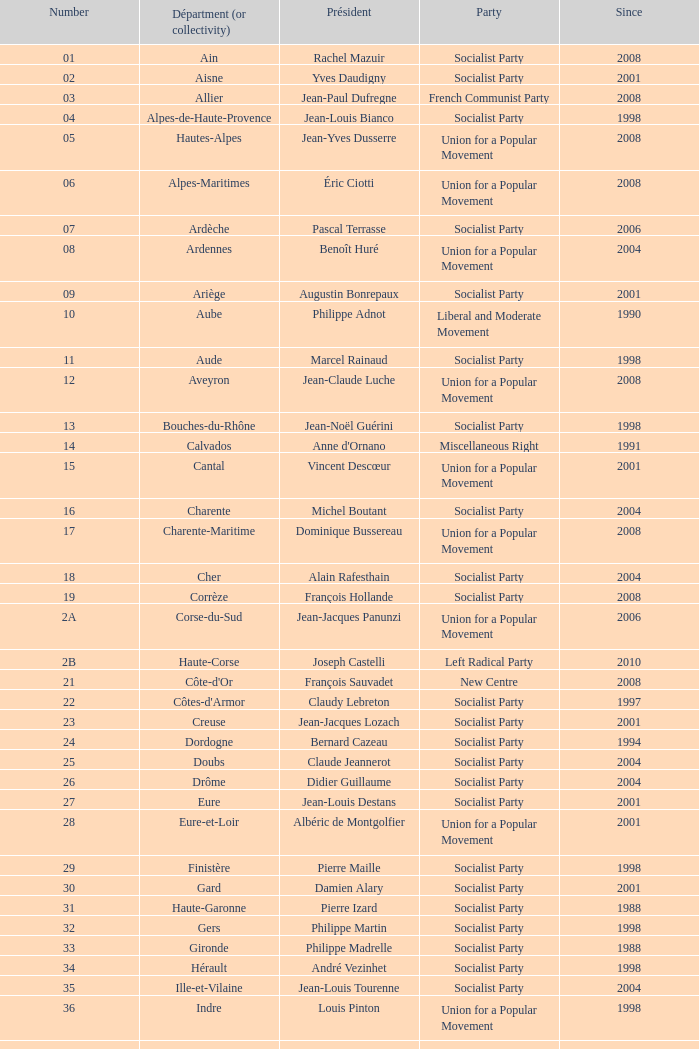Who is the president embodying the creuse department? Jean-Jacques Lozach. Could you parse the entire table? {'header': ['Number', 'Départment (or collectivity)', 'Président', 'Party', 'Since'], 'rows': [['01', 'Ain', 'Rachel Mazuir', 'Socialist Party', '2008'], ['02', 'Aisne', 'Yves Daudigny', 'Socialist Party', '2001'], ['03', 'Allier', 'Jean-Paul Dufregne', 'French Communist Party', '2008'], ['04', 'Alpes-de-Haute-Provence', 'Jean-Louis Bianco', 'Socialist Party', '1998'], ['05', 'Hautes-Alpes', 'Jean-Yves Dusserre', 'Union for a Popular Movement', '2008'], ['06', 'Alpes-Maritimes', 'Éric Ciotti', 'Union for a Popular Movement', '2008'], ['07', 'Ardèche', 'Pascal Terrasse', 'Socialist Party', '2006'], ['08', 'Ardennes', 'Benoît Huré', 'Union for a Popular Movement', '2004'], ['09', 'Ariège', 'Augustin Bonrepaux', 'Socialist Party', '2001'], ['10', 'Aube', 'Philippe Adnot', 'Liberal and Moderate Movement', '1990'], ['11', 'Aude', 'Marcel Rainaud', 'Socialist Party', '1998'], ['12', 'Aveyron', 'Jean-Claude Luche', 'Union for a Popular Movement', '2008'], ['13', 'Bouches-du-Rhône', 'Jean-Noël Guérini', 'Socialist Party', '1998'], ['14', 'Calvados', "Anne d'Ornano", 'Miscellaneous Right', '1991'], ['15', 'Cantal', 'Vincent Descœur', 'Union for a Popular Movement', '2001'], ['16', 'Charente', 'Michel Boutant', 'Socialist Party', '2004'], ['17', 'Charente-Maritime', 'Dominique Bussereau', 'Union for a Popular Movement', '2008'], ['18', 'Cher', 'Alain Rafesthain', 'Socialist Party', '2004'], ['19', 'Corrèze', 'François Hollande', 'Socialist Party', '2008'], ['2A', 'Corse-du-Sud', 'Jean-Jacques Panunzi', 'Union for a Popular Movement', '2006'], ['2B', 'Haute-Corse', 'Joseph Castelli', 'Left Radical Party', '2010'], ['21', "Côte-d'Or", 'François Sauvadet', 'New Centre', '2008'], ['22', "Côtes-d'Armor", 'Claudy Lebreton', 'Socialist Party', '1997'], ['23', 'Creuse', 'Jean-Jacques Lozach', 'Socialist Party', '2001'], ['24', 'Dordogne', 'Bernard Cazeau', 'Socialist Party', '1994'], ['25', 'Doubs', 'Claude Jeannerot', 'Socialist Party', '2004'], ['26', 'Drôme', 'Didier Guillaume', 'Socialist Party', '2004'], ['27', 'Eure', 'Jean-Louis Destans', 'Socialist Party', '2001'], ['28', 'Eure-et-Loir', 'Albéric de Montgolfier', 'Union for a Popular Movement', '2001'], ['29', 'Finistère', 'Pierre Maille', 'Socialist Party', '1998'], ['30', 'Gard', 'Damien Alary', 'Socialist Party', '2001'], ['31', 'Haute-Garonne', 'Pierre Izard', 'Socialist Party', '1988'], ['32', 'Gers', 'Philippe Martin', 'Socialist Party', '1998'], ['33', 'Gironde', 'Philippe Madrelle', 'Socialist Party', '1988'], ['34', 'Hérault', 'André Vezinhet', 'Socialist Party', '1998'], ['35', 'Ille-et-Vilaine', 'Jean-Louis Tourenne', 'Socialist Party', '2004'], ['36', 'Indre', 'Louis Pinton', 'Union for a Popular Movement', '1998'], ['37', 'Indre-et-Loire', 'Claude Roiron', 'Socialist Party', '2008'], ['38', 'Isère', 'André Vallini', 'Socialist Party', '2001'], ['39', 'Jura', 'Jean Raquin', 'Miscellaneous Right', '2008'], ['40', 'Landes', 'Henri Emmanuelli', 'Socialist Party', '1982'], ['41', 'Loir-et-Cher', 'Maurice Leroy', 'New Centre', '2004'], ['42', 'Loire', 'Bernard Bonne', 'Union for a Popular Movement', '2008'], ['43', 'Haute-Loire', 'Gérard Roche', 'Union for a Popular Movement', '2004'], ['44', 'Loire-Atlantique', 'Patrick Mareschal', 'Socialist Party', '2004'], ['45', 'Loiret', 'Éric Doligé', 'Union for a Popular Movement', '1994'], ['46', 'Lot', 'Gérard Miquel', 'Socialist Party', '2004'], ['47', 'Lot-et-Garonne', 'Pierre Camani', 'Socialist Party', '2008'], ['48', 'Lozère', 'Jean-Paul Pourquier', 'Union for a Popular Movement', '2004'], ['49', 'Maine-et-Loire', 'Christophe Béchu', 'Union for a Popular Movement', '2004'], ['50', 'Manche', 'Jean-François Le Grand', 'Union for a Popular Movement', '1998'], ['51', 'Marne', 'René-Paul Savary', 'Union for a Popular Movement', '2003'], ['52', 'Haute-Marne', 'Bruno Sido', 'Union for a Popular Movement', '1998'], ['53', 'Mayenne', 'Jean Arthuis', 'Miscellaneous Centre', '1992'], ['54', 'Meurthe-et-Moselle', 'Michel Dinet', 'Socialist Party', '1998'], ['55', 'Meuse', 'Christian Namy', 'Miscellaneous Right', '2004'], ['56', 'Morbihan', 'Joseph-François Kerguéris', 'Democratic Movement', '2004'], ['57', 'Moselle', 'Philippe Leroy', 'Union for a Popular Movement', '1992'], ['58', 'Nièvre', 'Marcel Charmant', 'Socialist Party', '2001'], ['59', 'Nord', 'Patrick Kanner', 'Socialist Party', '1998'], ['60', 'Oise', 'Yves Rome', 'Socialist Party', '2004'], ['61', 'Orne', 'Alain Lambert', 'Union for a Popular Movement', '2007'], ['62', 'Pas-de-Calais', 'Dominique Dupilet', 'Socialist Party', '2004'], ['63', 'Puy-de-Dôme', 'Jean-Yves Gouttebel', 'Socialist Party', '2004'], ['64', 'Pyrénées-Atlantiques', 'Jean Castaings', 'Union for a Popular Movement', '2008'], ['65', 'Hautes-Pyrénées', 'Josette Durrieu', 'Socialist Party', '2008'], ['66', 'Pyrénées-Orientales', 'Christian Bourquin', 'Socialist Party', '1998'], ['67', 'Bas-Rhin', 'Guy-Dominique Kennel', 'Union for a Popular Movement', '2008'], ['68', 'Haut-Rhin', 'Charles Buttner', 'Union for a Popular Movement', '2004'], ['69', 'Rhône', 'Michel Mercier', 'Miscellaneous Centre', '1990'], ['70', 'Haute-Saône', 'Yves Krattinger', 'Socialist Party', '2002'], ['71', 'Saône-et-Loire', 'Arnaud Montebourg', 'Socialist Party', '2008'], ['72', 'Sarthe', 'Roland du Luart', 'Union for a Popular Movement', '1998'], ['73', 'Savoie', 'Hervé Gaymard', 'Union for a Popular Movement', '2008'], ['74', 'Haute-Savoie', 'Christian Monteil', 'Miscellaneous Right', '2008'], ['75', 'Paris', 'Bertrand Delanoë', 'Socialist Party', '2001'], ['76', 'Seine-Maritime', 'Didier Marie', 'Socialist Party', '2004'], ['77', 'Seine-et-Marne', 'Vincent Eblé', 'Socialist Party', '2004'], ['78', 'Yvelines', 'Pierre Bédier', 'Union for a Popular Movement', '2005'], ['79', 'Deux-Sèvres', 'Éric Gautier', 'Socialist Party', '2008'], ['80', 'Somme', 'Christian Manable', 'Socialist Party', '2008'], ['81', 'Tarn', 'Thierry Carcenac', 'Socialist Party', '1991'], ['82', 'Tarn-et-Garonne', 'Jean-Michel Baylet', 'Left Radical Party', '1986'], ['83', 'Var', 'Horace Lanfranchi', 'Union for a Popular Movement', '2002'], ['84', 'Vaucluse', 'Claude Haut', 'Socialist Party', '2001'], ['85', 'Vendée', 'Philippe de Villiers', 'Movement for France', '1988'], ['86', 'Vienne', 'Claude Bertaud', 'Union for a Popular Movement', '2008'], ['87', 'Haute-Vienne', 'Marie-Françoise Pérol-Dumont', 'Socialist Party', '2004'], ['88', 'Vosges', 'Christian Poncelet', 'Union for a Popular Movement', '1976'], ['89', 'Yonne', 'Jean-Marie Rolland', 'Union for a Popular Movement', '2008'], ['90', 'Territoire de Belfort', 'Yves Ackermann', 'Socialist Party', '2004'], ['91', 'Essonne', 'Michel Berson', 'Socialist Party', '1998'], ['92', 'Hauts-de-Seine', 'Patrick Devedjian', 'Union for a Popular Movement', '2007'], ['93', 'Seine-Saint-Denis', 'Claude Bartolone', 'Socialist Party', '2008'], ['94', 'Val-de-Marne', 'Christian Favier', 'French Communist Party', '2001'], ['95', 'Val-d’Oise', 'Arnaud Bazin', 'Union for a Popular Movement', '2011'], ['971', 'Guadeloupe', 'Jacques Gillot', 'United Guadeloupe, Socialism and Realities', '2001'], ['972', 'Martinique', 'Claude Lise', 'Martinican Democratic Rally', '1992'], ['973', 'Guyane', 'Alain Tien-Liong', 'Miscellaneous Left', '2008'], ['974', 'Réunion', 'Nassimah Dindar', 'Union for a Popular Movement', '2004'], ['975', 'Saint-Pierre-et-Miquelon (overseas collect.)', 'Stéphane Artano', 'Archipelago Tomorrow', '2006'], ['976', 'Mayotte (overseas collect.)', 'Ahmed Attoumani Douchina', 'Union for a Popular Movement', '2008']]} 